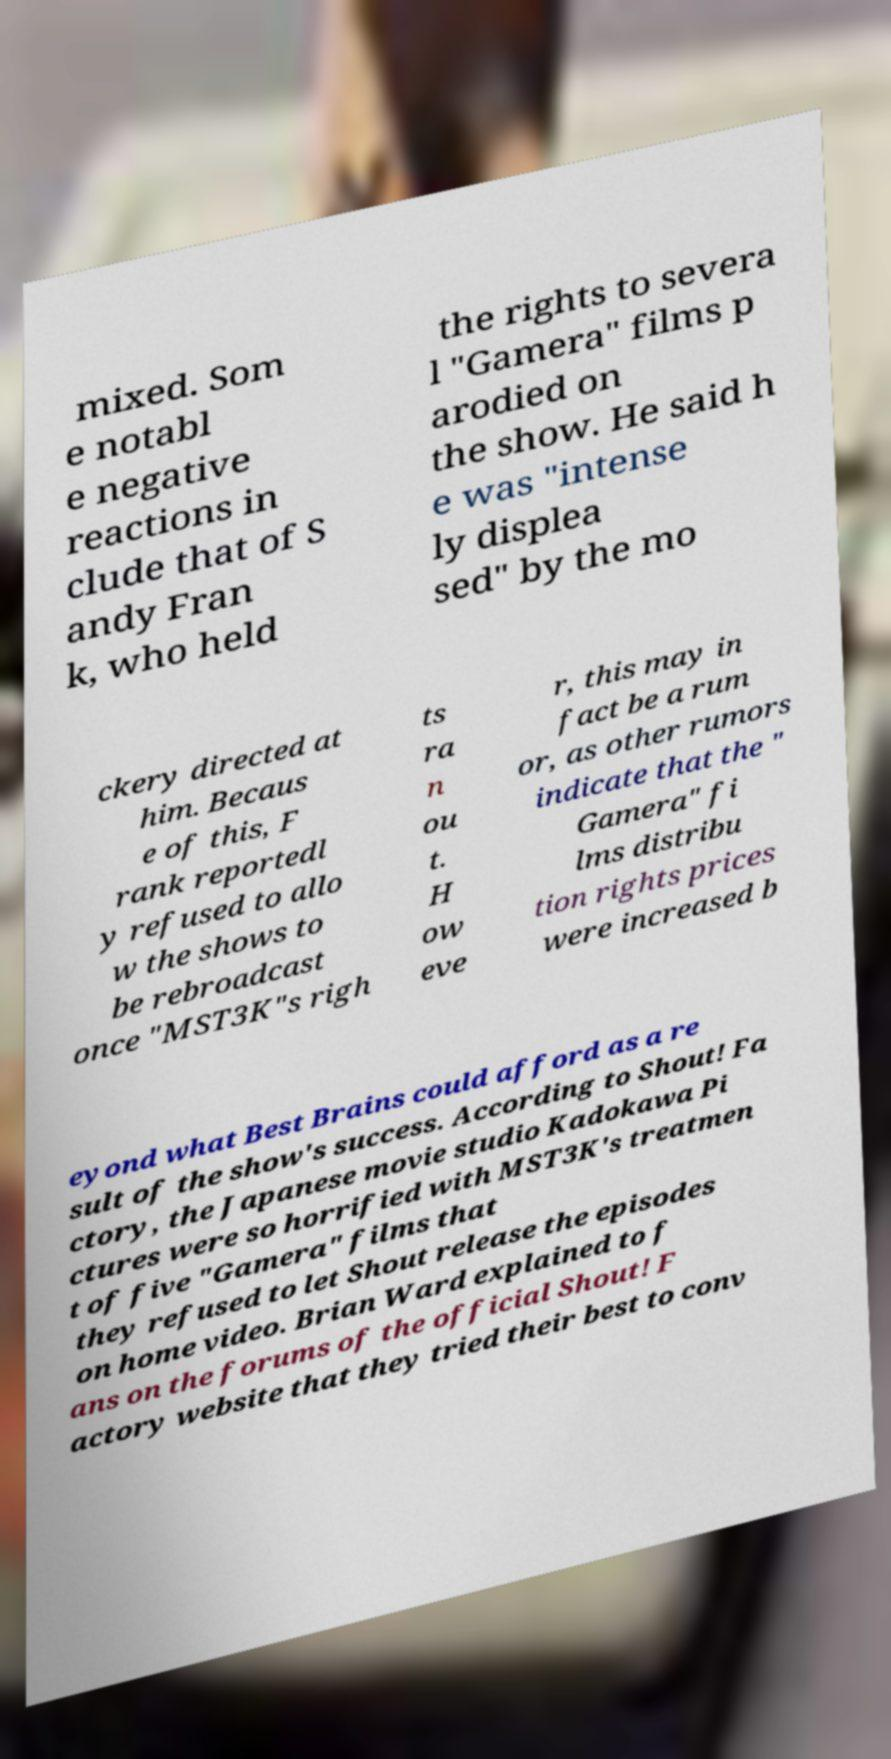Can you accurately transcribe the text from the provided image for me? mixed. Som e notabl e negative reactions in clude that of S andy Fran k, who held the rights to severa l "Gamera" films p arodied on the show. He said h e was "intense ly displea sed" by the mo ckery directed at him. Becaus e of this, F rank reportedl y refused to allo w the shows to be rebroadcast once "MST3K"s righ ts ra n ou t. H ow eve r, this may in fact be a rum or, as other rumors indicate that the " Gamera" fi lms distribu tion rights prices were increased b eyond what Best Brains could afford as a re sult of the show's success. According to Shout! Fa ctory, the Japanese movie studio Kadokawa Pi ctures were so horrified with MST3K's treatmen t of five "Gamera" films that they refused to let Shout release the episodes on home video. Brian Ward explained to f ans on the forums of the official Shout! F actory website that they tried their best to conv 